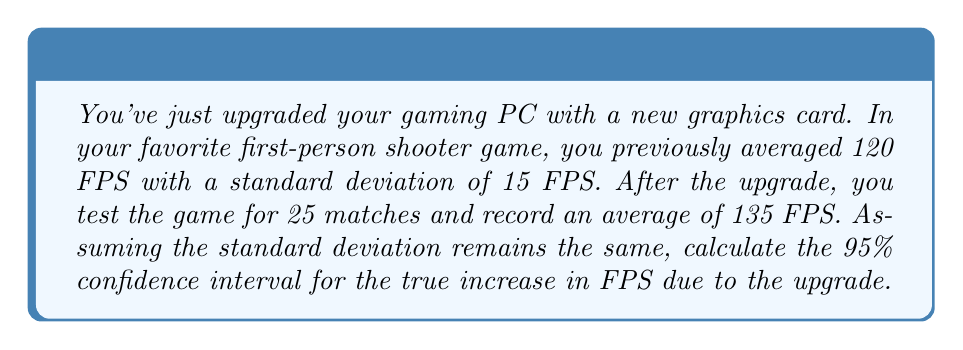Can you solve this math problem? Let's approach this step-by-step:

1) We're dealing with a paired difference test, where we're interested in the difference between the new and old FPS.

2) The point estimate for the increase is:
   $\bar{d} = 135 - 120 = 15$ FPS

3) We assume the standard deviation remains the same at 15 FPS. For a paired difference, we use the standard error of the mean difference:
   $SE_{\bar{d}} = \frac{s}{\sqrt{n}} = \frac{15}{\sqrt{25}} = 3$ FPS

4) For a 95% confidence interval, we use the t-distribution with 24 degrees of freedom (n-1). The critical t-value is approximately 2.064.

5) The confidence interval is calculated as:
   $\bar{d} \pm t_{0.025,24} \times SE_{\bar{d}}$

6) Plugging in our values:
   $15 \pm 2.064 \times 3$

7) This simplifies to:
   $15 \pm 6.192$

8) Therefore, the 95% confidence interval is:
   $(15 - 6.192, 15 + 6.192) = (8.808, 21.192)$
Answer: (8.81, 21.19) FPS 